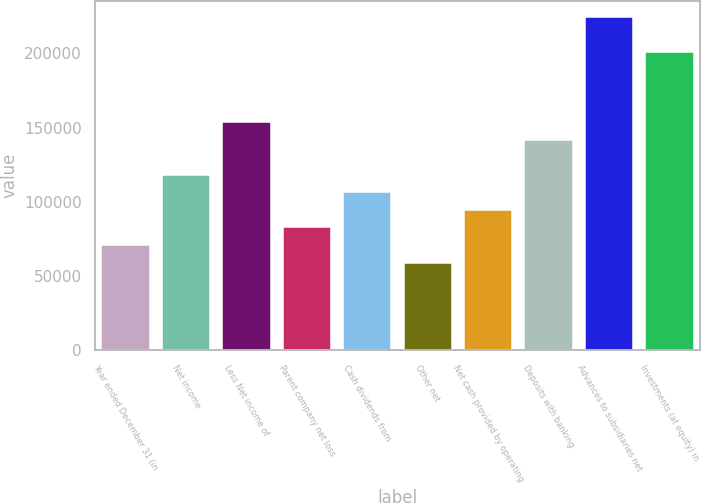<chart> <loc_0><loc_0><loc_500><loc_500><bar_chart><fcel>Year ended December 31 (in<fcel>Net income<fcel>Less Net income of<fcel>Parent company net loss<fcel>Cash dividends from<fcel>Other net<fcel>Net cash provided by operating<fcel>Deposits with banking<fcel>Advances to subsidiaries net<fcel>Investments (at equity) in<nl><fcel>70869.8<fcel>118093<fcel>153510<fcel>82675.6<fcel>106287<fcel>59064<fcel>94481.4<fcel>141705<fcel>224345<fcel>200734<nl></chart> 